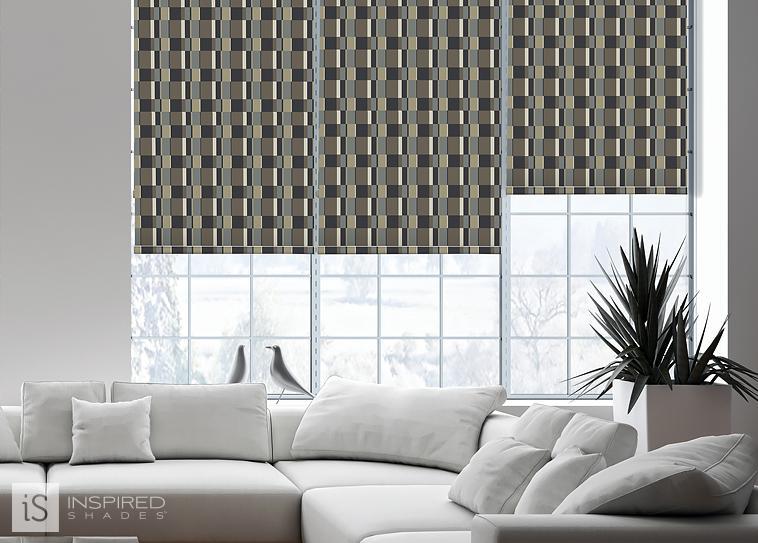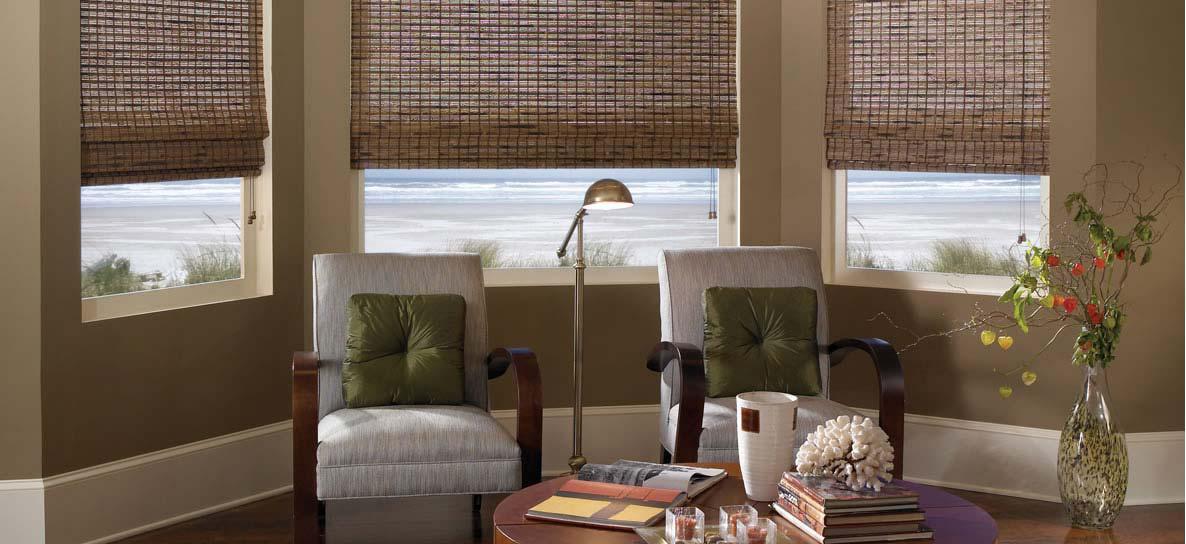The first image is the image on the left, the second image is the image on the right. Evaluate the accuracy of this statement regarding the images: "There are a total of six blinds.". Is it true? Answer yes or no. Yes. The first image is the image on the left, the second image is the image on the right. For the images displayed, is the sentence "There are exactly six window shades." factually correct? Answer yes or no. Yes. 